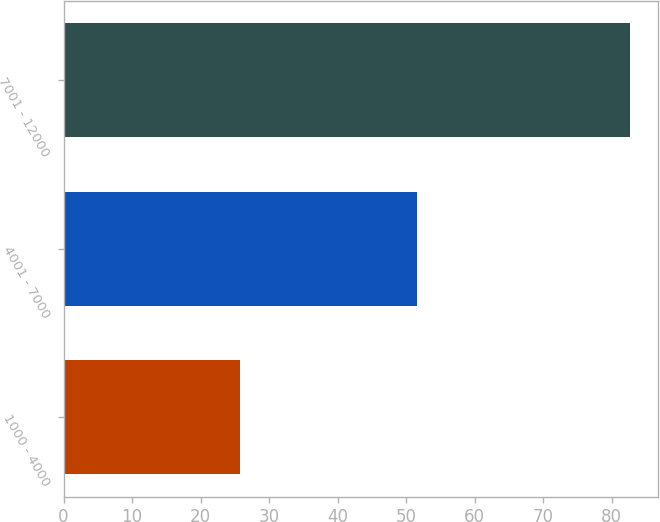Convert chart to OTSL. <chart><loc_0><loc_0><loc_500><loc_500><bar_chart><fcel>1000 - 4000<fcel>4001 - 7000<fcel>7001 - 12000<nl><fcel>25.78<fcel>51.65<fcel>82.62<nl></chart> 